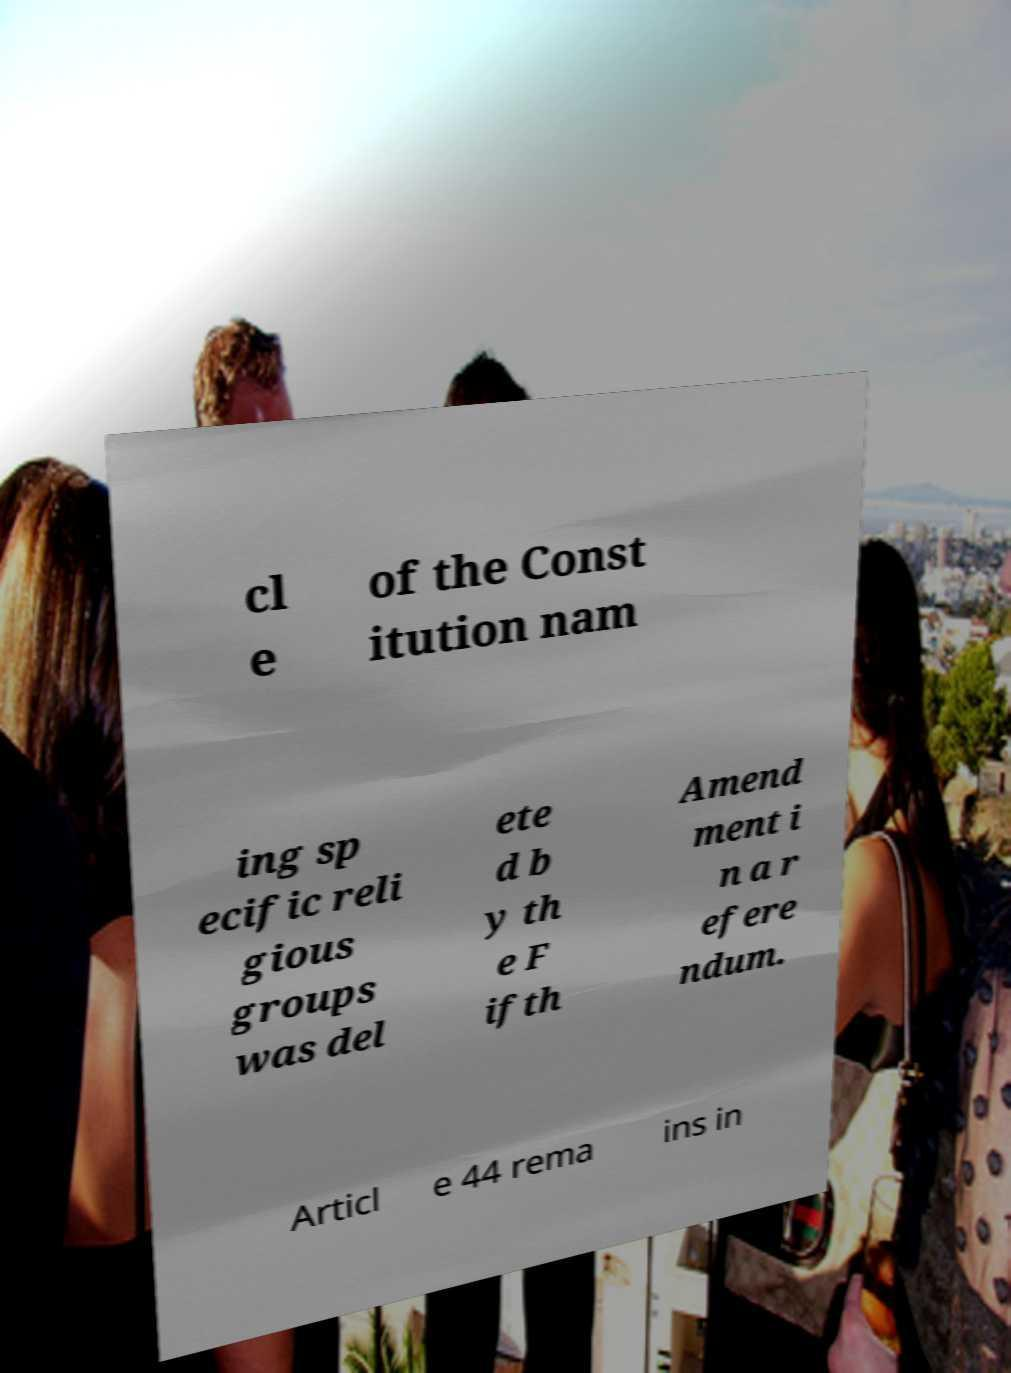Please read and relay the text visible in this image. What does it say? cl e of the Const itution nam ing sp ecific reli gious groups was del ete d b y th e F ifth Amend ment i n a r efere ndum. Articl e 44 rema ins in 